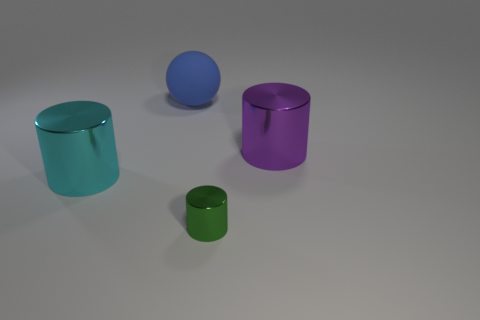Subtract all big purple metallic cylinders. How many cylinders are left? 2 Add 1 big purple metal objects. How many objects exist? 5 Subtract all cylinders. How many objects are left? 1 Subtract 1 purple cylinders. How many objects are left? 3 Subtract all small green cylinders. Subtract all big rubber objects. How many objects are left? 2 Add 1 large cylinders. How many large cylinders are left? 3 Add 4 cyan metal things. How many cyan metal things exist? 5 